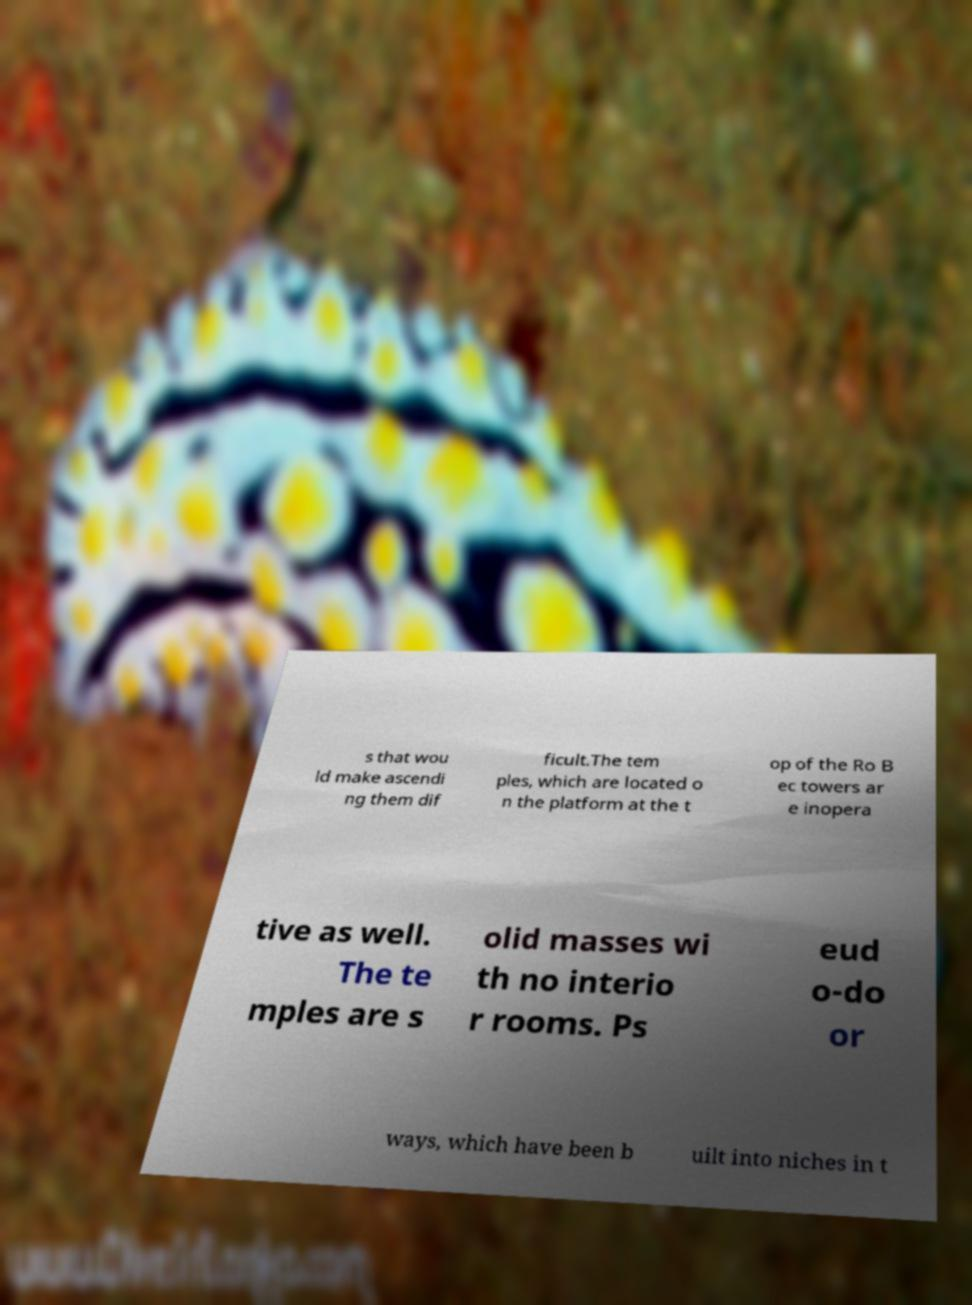What messages or text are displayed in this image? I need them in a readable, typed format. s that wou ld make ascendi ng them dif ficult.The tem ples, which are located o n the platform at the t op of the Ro B ec towers ar e inopera tive as well. The te mples are s olid masses wi th no interio r rooms. Ps eud o-do or ways, which have been b uilt into niches in t 